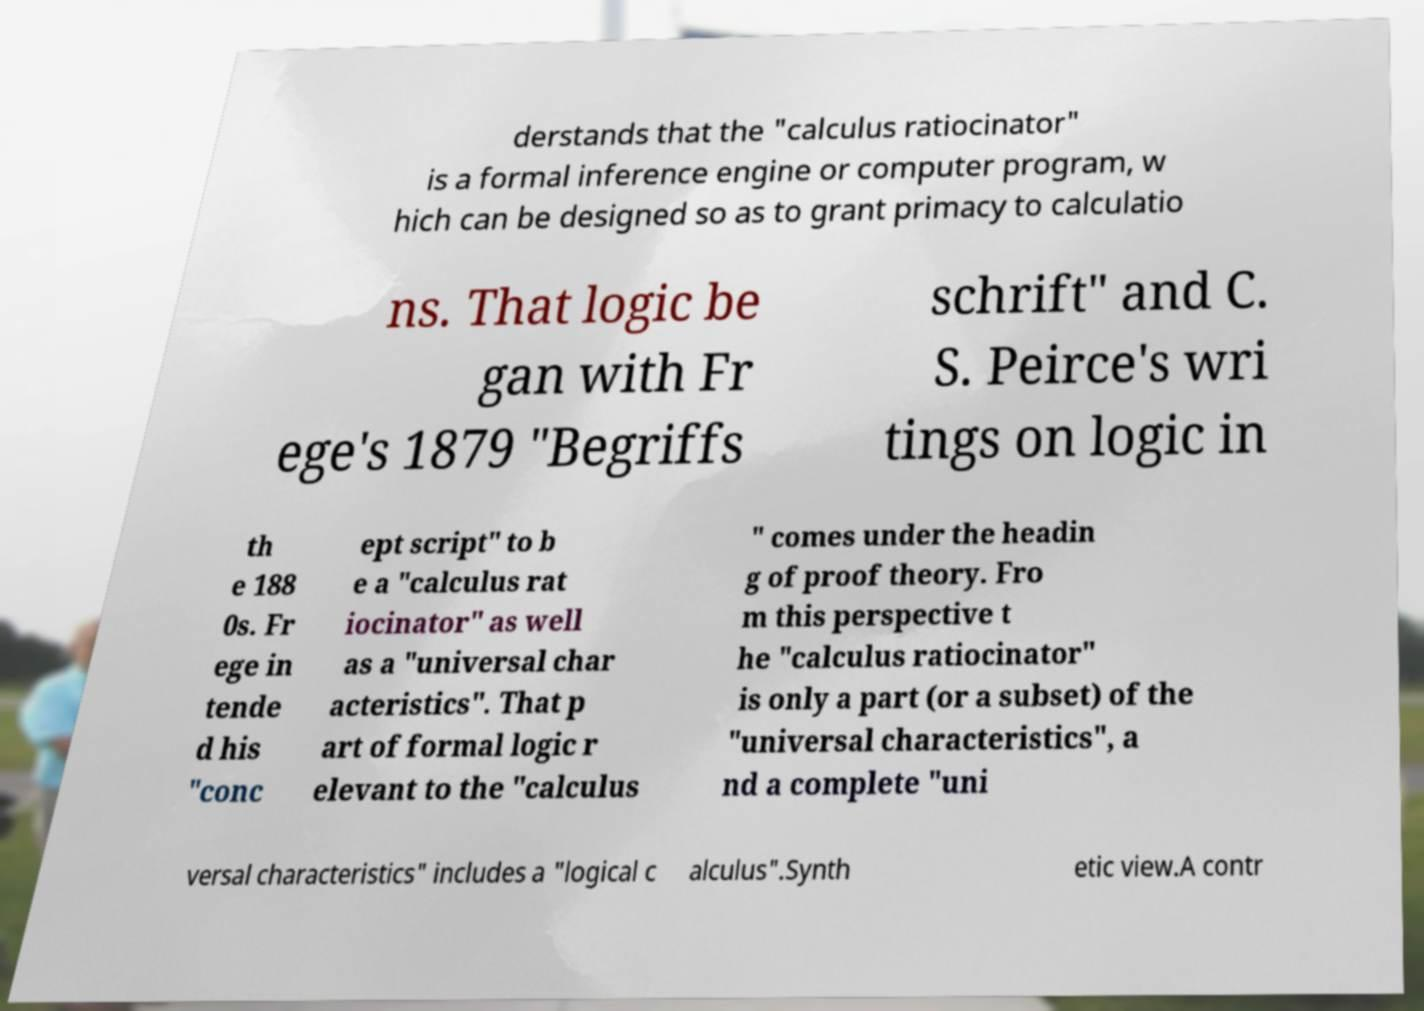Could you extract and type out the text from this image? derstands that the "calculus ratiocinator" is a formal inference engine or computer program, w hich can be designed so as to grant primacy to calculatio ns. That logic be gan with Fr ege's 1879 "Begriffs schrift" and C. S. Peirce's wri tings on logic in th e 188 0s. Fr ege in tende d his "conc ept script" to b e a "calculus rat iocinator" as well as a "universal char acteristics". That p art of formal logic r elevant to the "calculus " comes under the headin g of proof theory. Fro m this perspective t he "calculus ratiocinator" is only a part (or a subset) of the "universal characteristics", a nd a complete "uni versal characteristics" includes a "logical c alculus".Synth etic view.A contr 